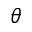Convert formula to latex. <formula><loc_0><loc_0><loc_500><loc_500>\theta</formula> 